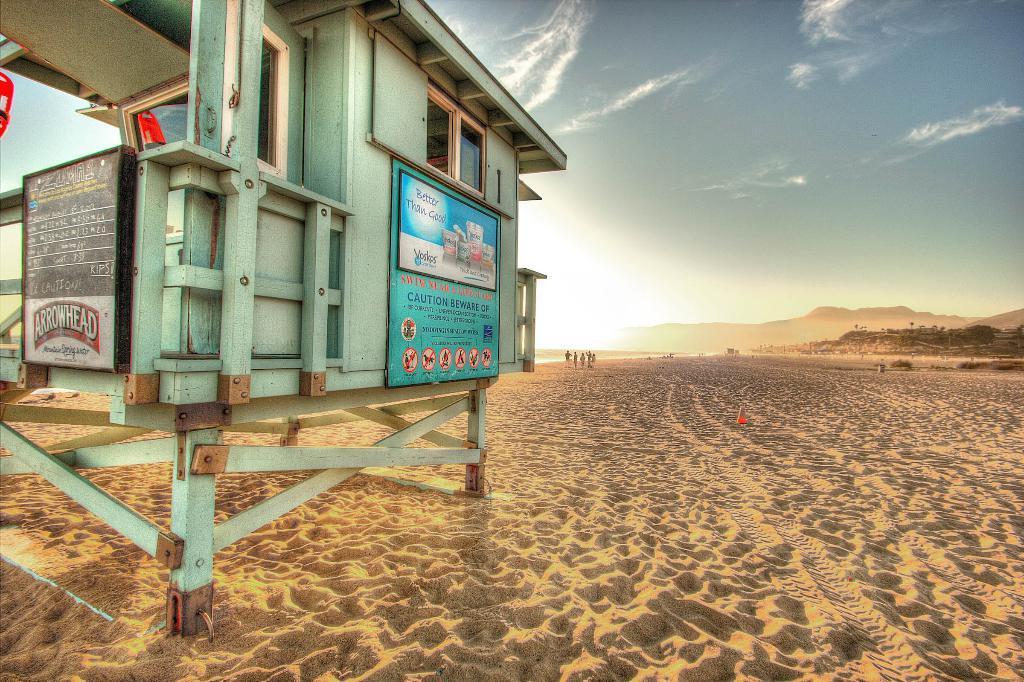In one or two sentences, can you explain what this image depicts? In this picture there is a signage on the left side of the image and there are people in the background area of the image, it seems to be the place of desert. 